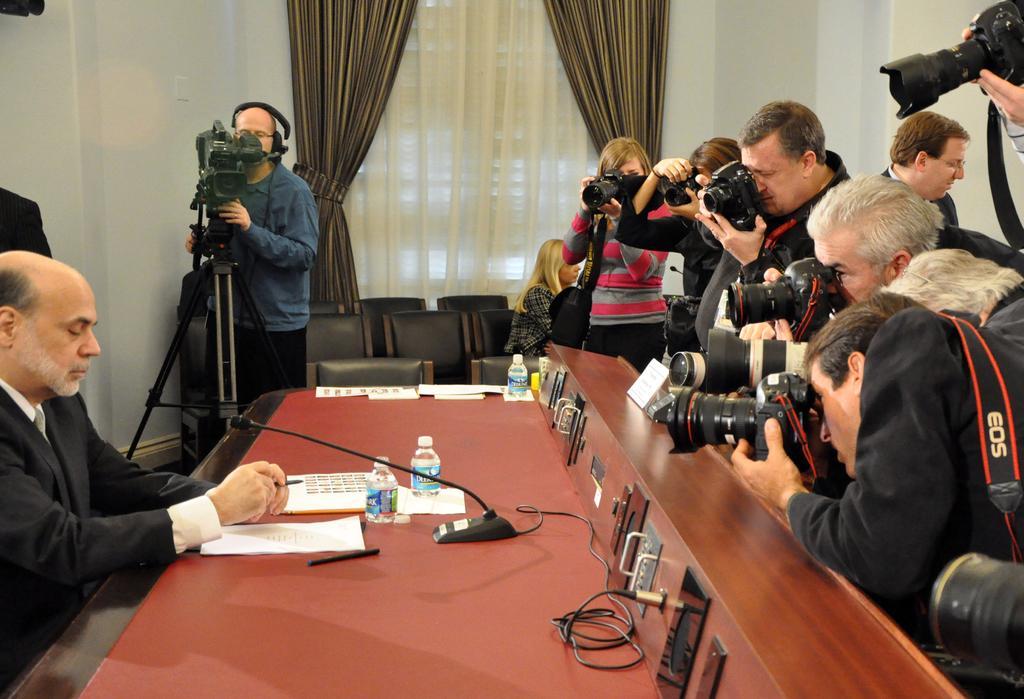In one or two sentences, can you explain what this image depicts? In this image we can see a man is sitting. He is wearing black color suit with white shirt. In front of him, a wooden table is there. On table, we can see bottles, papers, pen and wire. We can see men and women are standing by holding camera in their hands on the right side of the image. We can see black color chairs, curtain, white wall and one man in the background. The man is wearing blue color shirt with black pant and in front of the man, tripod stand and camera is there. 